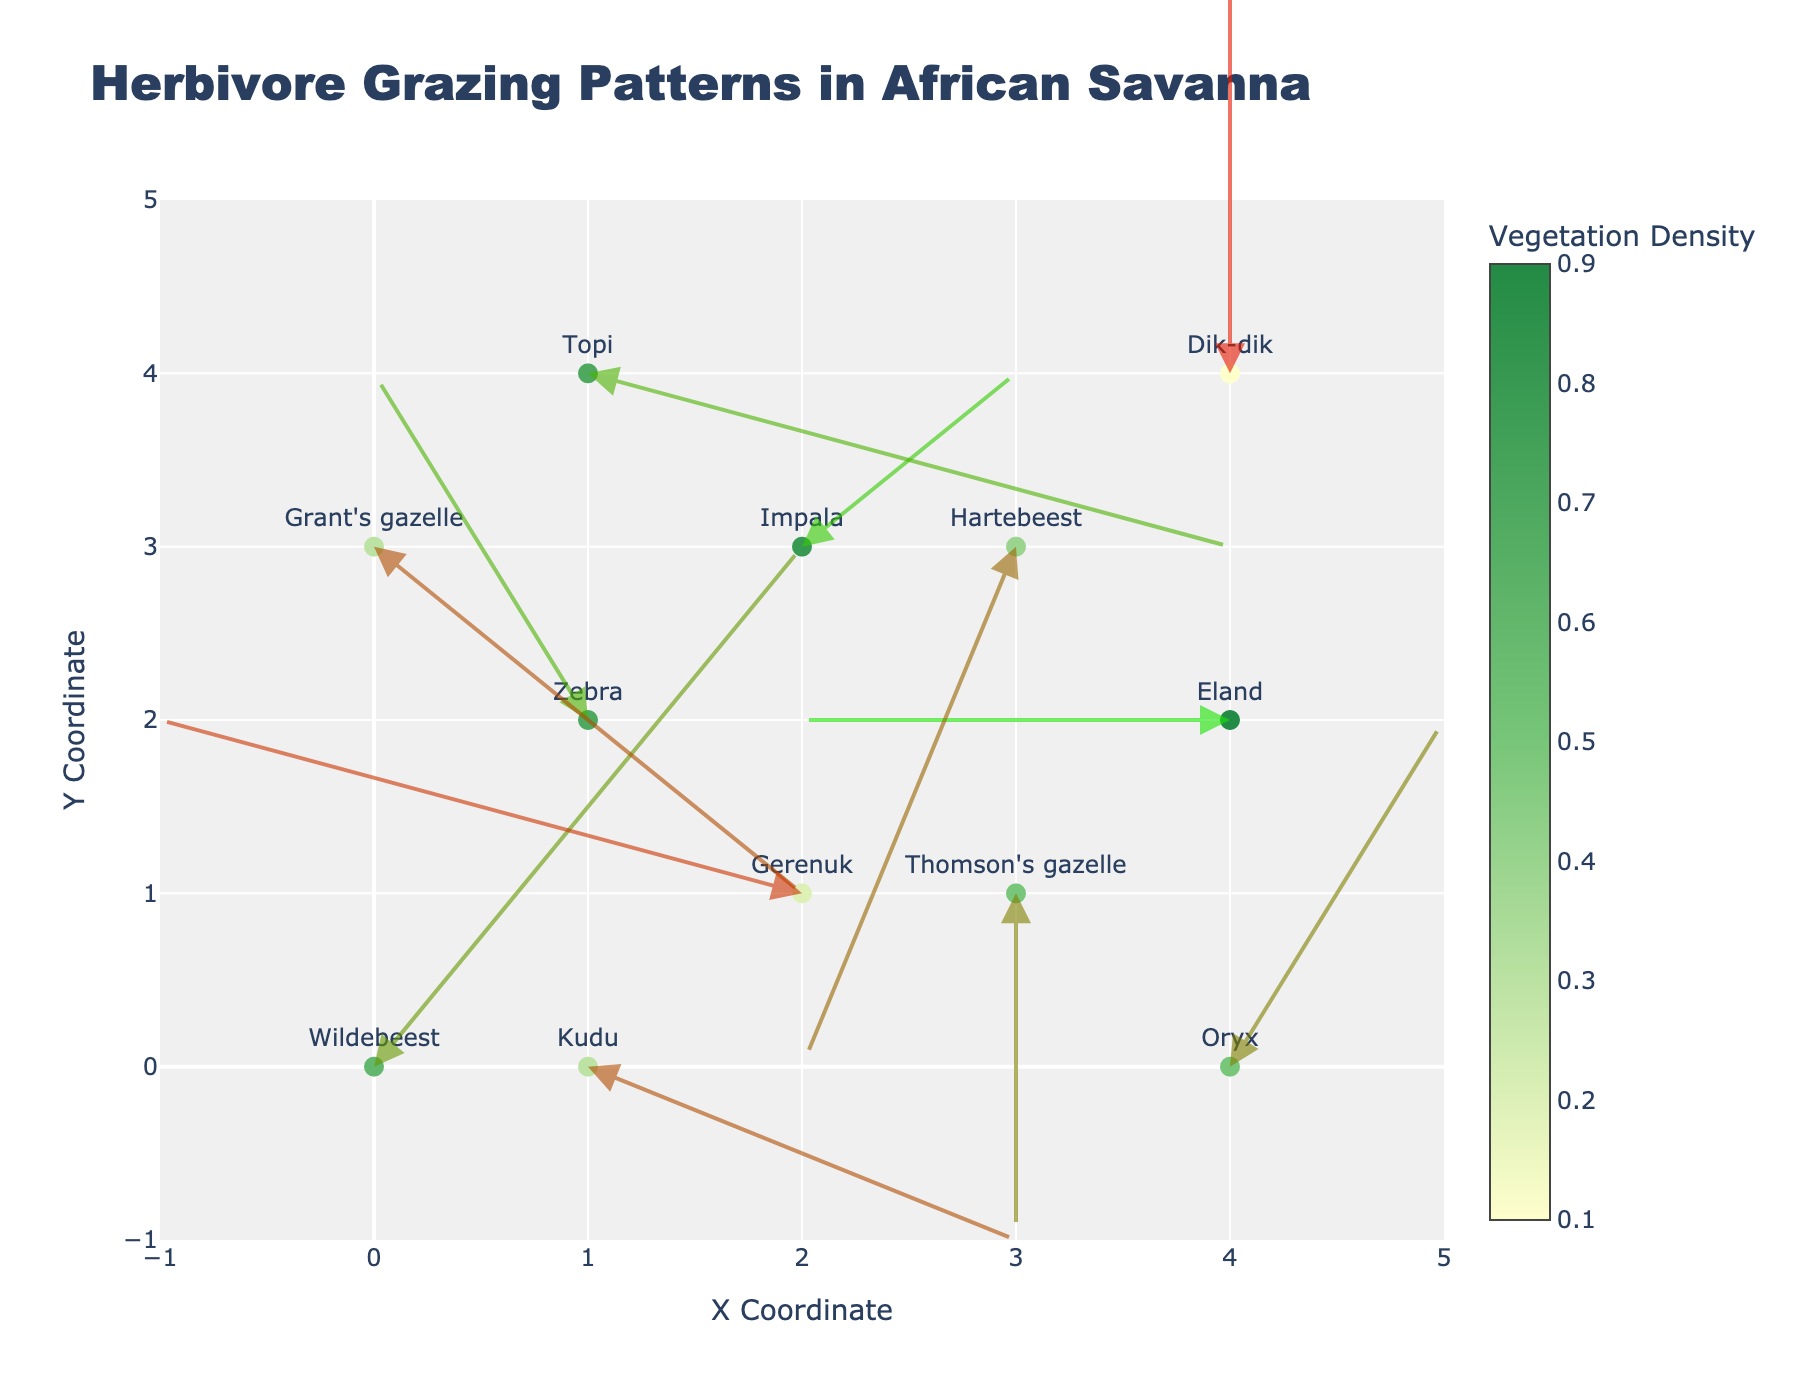How many distinct herbivore species are shown in the plot? The plot includes 11 points, each labeled with different herbivore species. Counting the unique names gives the number of distinct species.
Answer: 11 Which season shows the highest average vegetation density? By averaging the vegetation densities for each season: Spring has (0.6 + 0.7 + 0.5) / 3 = 0.6; Summer has (0.8 + 0.9 + 0.7) / 3 = 0.8; Autumn has (0.4 + 0.3 + 0.5) / 3 ≈ 0.4; Winter has (0.2 + 0.1 + 0.3) / 3 = 0.2.
Answer: Summer What is the relationship between vegetation density and arrow color? The arrow colors vary based on the vegetation density. Higher densities have more green (higher G value in RGB), while lower densities have more red (higher R value in RGB).
Answer: Higher density, greener arrows Which herbivore species is associated with the lowest vegetation density? By checking each data point's hover text or labels for vegetation density, the lowest value is 0.1, associated with the species "Dik-dik" in Winter.
Answer: Dik-dik During which season do herbivores predominantly move upwards (increasing y)? The quiver plot shows movement directions. For Spring: 2 upwards, 1 downwards; Summer: 2 upwards, 1 downwards; Autumn: 1 upwards, 2 downwards; Winter: 1 upwards, 2 downwards. Therefore, Spring and Summer predominantly have upwards movement.
Answer: Spring and Summer Compare the vegetation density between Spring and Autumn. Which one has a higher variance? Spring vegetation densities are [0.6, 0.7, 0.5], and Autumn has [0.4, 0.3, 0.5]. Variance can be calculated manually or inferred from visual inspection of the spread of values. Spring's values are closer together, suggesting lower variance compared to Autumn.
Answer: Autumn Which movement direction (u,v) suggests the longest distance traveled by an herbivore? The distance traveled can be calculated as √(u² + v²). For example, (2, 3) for Wildebeest in Spring gives √(2² + 3²) = √13. Calculating this for all pairs, the pair (3, -1) for Topi in Summer, gives the greatest distance, √(3² + (-1)²) = √10 ≈ 3.16. Other movements all result in smaller values.
Answer: (2, 3) Are there any instances where the herbivore moves in a strictly vertical or horizontal direction? Strictly vertical movement would have u = 0 and strictly horizontal movement would have v = 0. Checking the data: "Thomson's gazelle" in Spring has u=0; "Eland" in Summer has v=0.
Answer: Yes, "Thomson's gazelle" and "Eland" 